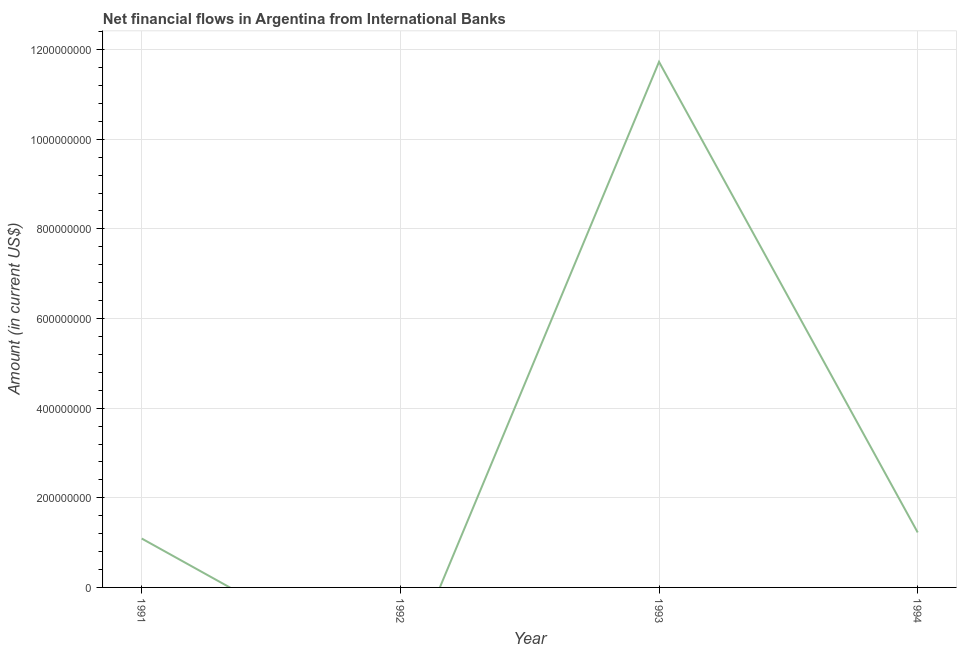What is the net financial flows from ibrd in 1992?
Offer a terse response. 0. Across all years, what is the maximum net financial flows from ibrd?
Your answer should be compact. 1.17e+09. Across all years, what is the minimum net financial flows from ibrd?
Your answer should be very brief. 0. What is the sum of the net financial flows from ibrd?
Keep it short and to the point. 1.40e+09. What is the difference between the net financial flows from ibrd in 1993 and 1994?
Offer a terse response. 1.05e+09. What is the average net financial flows from ibrd per year?
Your answer should be very brief. 3.51e+08. What is the median net financial flows from ibrd?
Provide a succinct answer. 1.16e+08. In how many years, is the net financial flows from ibrd greater than 400000000 US$?
Offer a terse response. 1. What is the ratio of the net financial flows from ibrd in 1991 to that in 1994?
Make the answer very short. 0.89. Is the net financial flows from ibrd in 1993 less than that in 1994?
Provide a succinct answer. No. Is the difference between the net financial flows from ibrd in 1991 and 1994 greater than the difference between any two years?
Keep it short and to the point. No. What is the difference between the highest and the second highest net financial flows from ibrd?
Make the answer very short. 1.05e+09. Is the sum of the net financial flows from ibrd in 1991 and 1993 greater than the maximum net financial flows from ibrd across all years?
Provide a short and direct response. Yes. What is the difference between the highest and the lowest net financial flows from ibrd?
Make the answer very short. 1.17e+09. How many lines are there?
Keep it short and to the point. 1. What is the difference between two consecutive major ticks on the Y-axis?
Offer a very short reply. 2.00e+08. Does the graph contain any zero values?
Keep it short and to the point. Yes. What is the title of the graph?
Provide a succinct answer. Net financial flows in Argentina from International Banks. What is the label or title of the Y-axis?
Make the answer very short. Amount (in current US$). What is the Amount (in current US$) of 1991?
Keep it short and to the point. 1.09e+08. What is the Amount (in current US$) in 1992?
Provide a succinct answer. 0. What is the Amount (in current US$) in 1993?
Offer a terse response. 1.17e+09. What is the Amount (in current US$) in 1994?
Give a very brief answer. 1.23e+08. What is the difference between the Amount (in current US$) in 1991 and 1993?
Offer a terse response. -1.06e+09. What is the difference between the Amount (in current US$) in 1991 and 1994?
Your response must be concise. -1.35e+07. What is the difference between the Amount (in current US$) in 1993 and 1994?
Offer a terse response. 1.05e+09. What is the ratio of the Amount (in current US$) in 1991 to that in 1993?
Provide a short and direct response. 0.09. What is the ratio of the Amount (in current US$) in 1991 to that in 1994?
Offer a very short reply. 0.89. What is the ratio of the Amount (in current US$) in 1993 to that in 1994?
Ensure brevity in your answer.  9.56. 